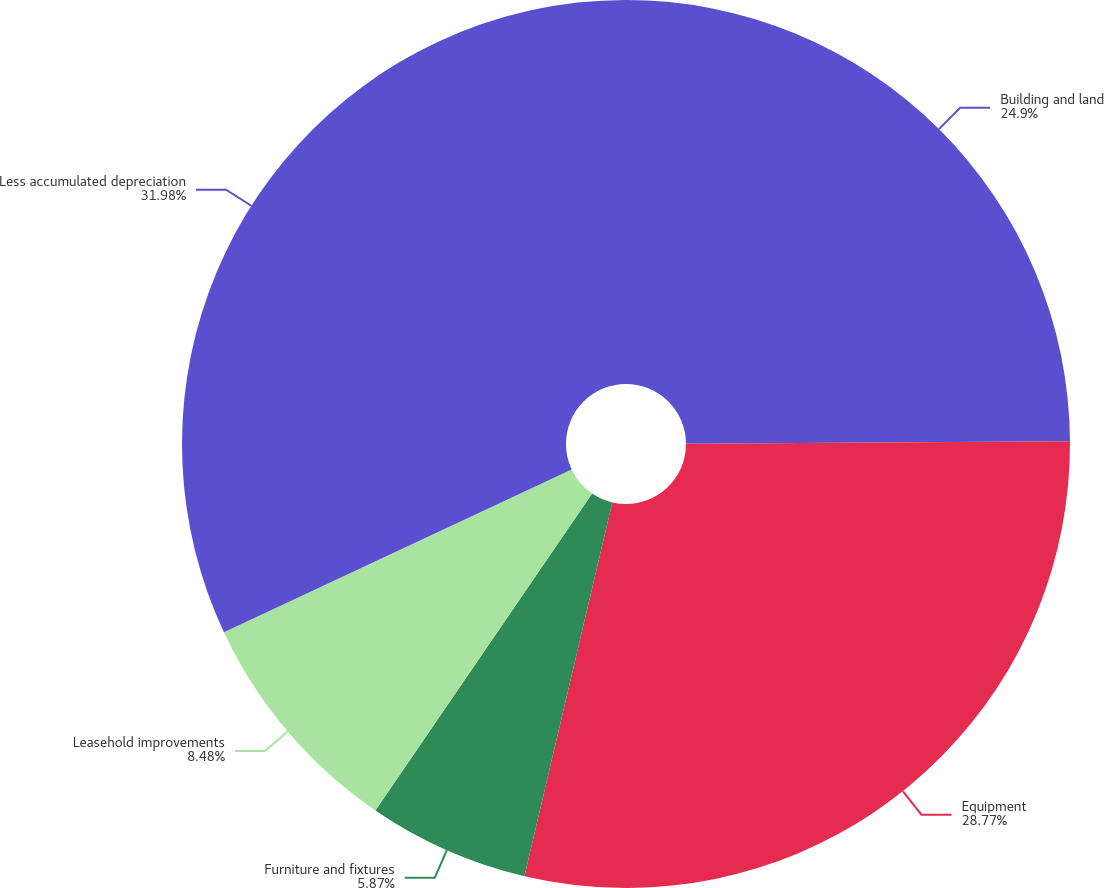<chart> <loc_0><loc_0><loc_500><loc_500><pie_chart><fcel>Building and land<fcel>Equipment<fcel>Furniture and fixtures<fcel>Leasehold improvements<fcel>Less accumulated depreciation<nl><fcel>24.9%<fcel>28.77%<fcel>5.87%<fcel>8.48%<fcel>31.97%<nl></chart> 